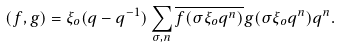<formula> <loc_0><loc_0><loc_500><loc_500>( f , g ) = \xi _ { o } ( q - q ^ { - 1 } ) \sum _ { \sigma , n } \overline { f ( \sigma \xi _ { o } q ^ { n } ) } g ( \sigma \xi _ { o } q ^ { n } ) q ^ { n } .</formula> 